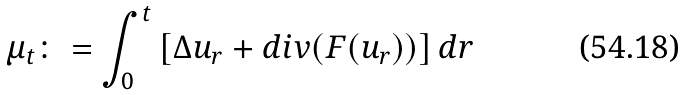<formula> <loc_0><loc_0><loc_500><loc_500>\mu _ { t } \colon = \int _ { 0 } ^ { t } \left [ \Delta u _ { r } + d i v ( F ( u _ { r } ) ) \right ] d r</formula> 